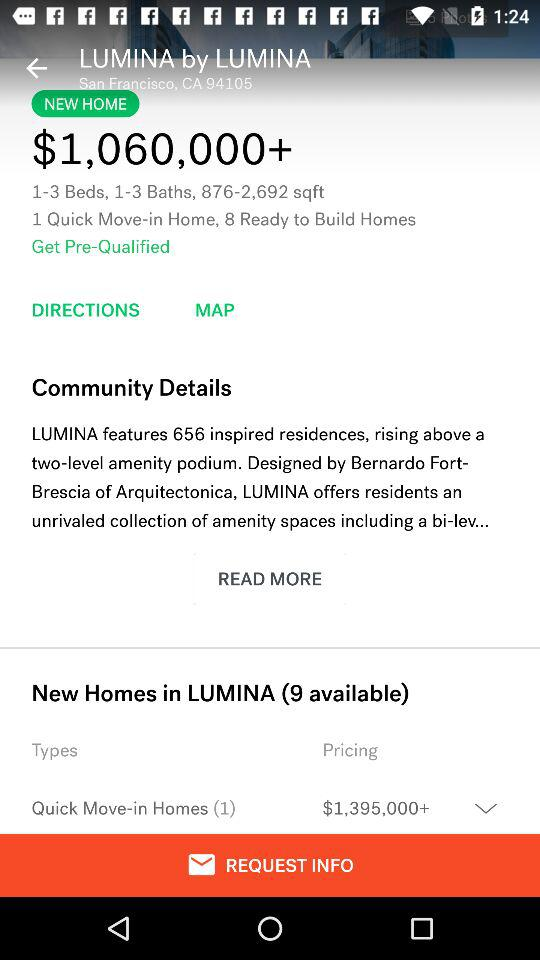What is the price of a new home in "LUMINA" by "LUMINA"? The price of a new home in "LUMINA" by "LUMINA" is more than $1,060,000. 